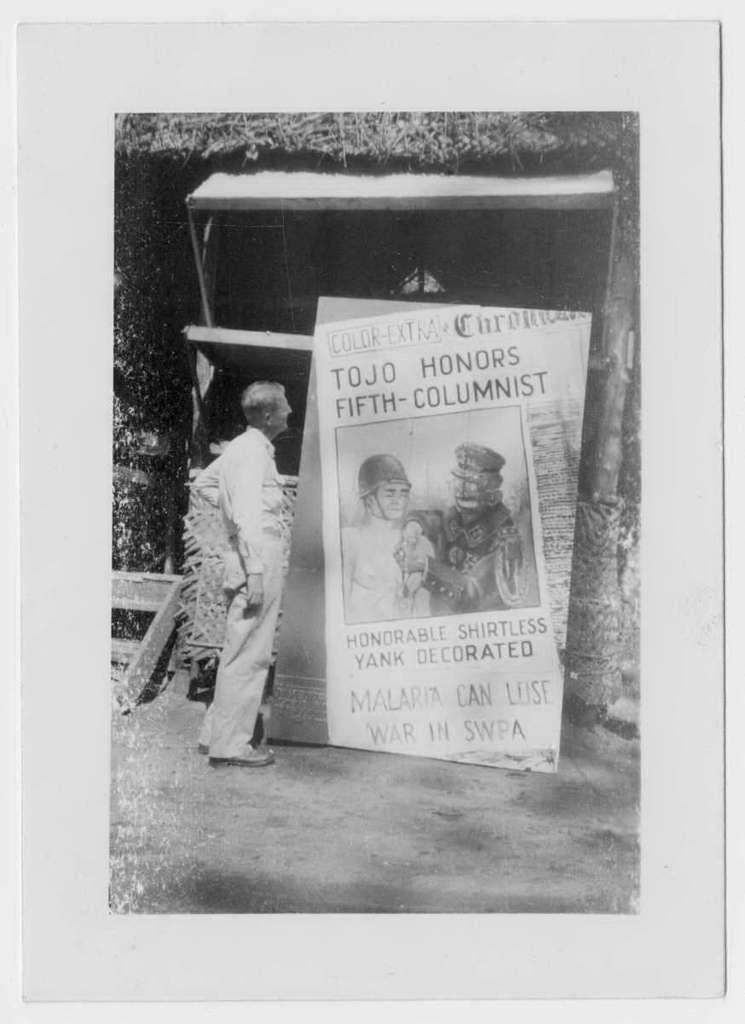In one or two sentences, can you explain what this image depicts? In the image we can see the black and white picture of a person standing and wearing clothes. There is even the poster and in the poster we can see the text and photos of two people. Here we can see the pole and the plants. 